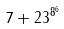<formula> <loc_0><loc_0><loc_500><loc_500>7 + 2 3 ^ { 8 ^ { 6 } }</formula> 